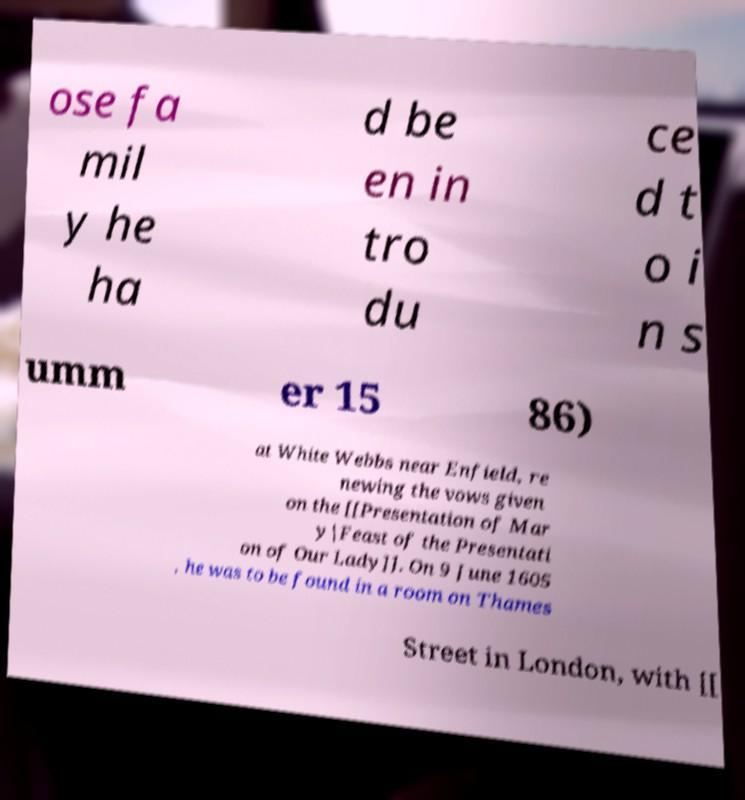What messages or text are displayed in this image? I need them in a readable, typed format. ose fa mil y he ha d be en in tro du ce d t o i n s umm er 15 86) at White Webbs near Enfield, re newing the vows given on the [[Presentation of Mar y|Feast of the Presentati on of Our Lady]]. On 9 June 1605 , he was to be found in a room on Thames Street in London, with [[ 